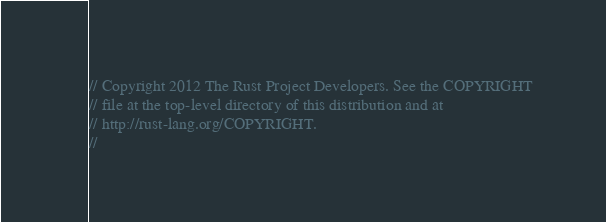<code> <loc_0><loc_0><loc_500><loc_500><_Rust_>// Copyright 2012 The Rust Project Developers. See the COPYRIGHT
// file at the top-level directory of this distribution and at
// http://rust-lang.org/COPYRIGHT.
//</code> 